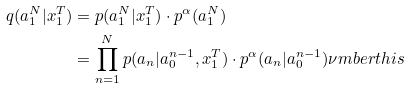<formula> <loc_0><loc_0><loc_500><loc_500>q ( a _ { 1 } ^ { N } | x _ { 1 } ^ { T } ) & = p ( a _ { 1 } ^ { N } | x _ { 1 } ^ { T } ) \cdot p ^ { \alpha } ( a _ { 1 } ^ { N } ) \\ & = \prod _ { n = 1 } ^ { N } p ( a _ { n } | a _ { 0 } ^ { n - 1 } , x _ { 1 } ^ { T } ) \cdot p ^ { \alpha } ( a _ { n } | a _ { 0 } ^ { n - 1 } ) \nu m b e r t h i s</formula> 